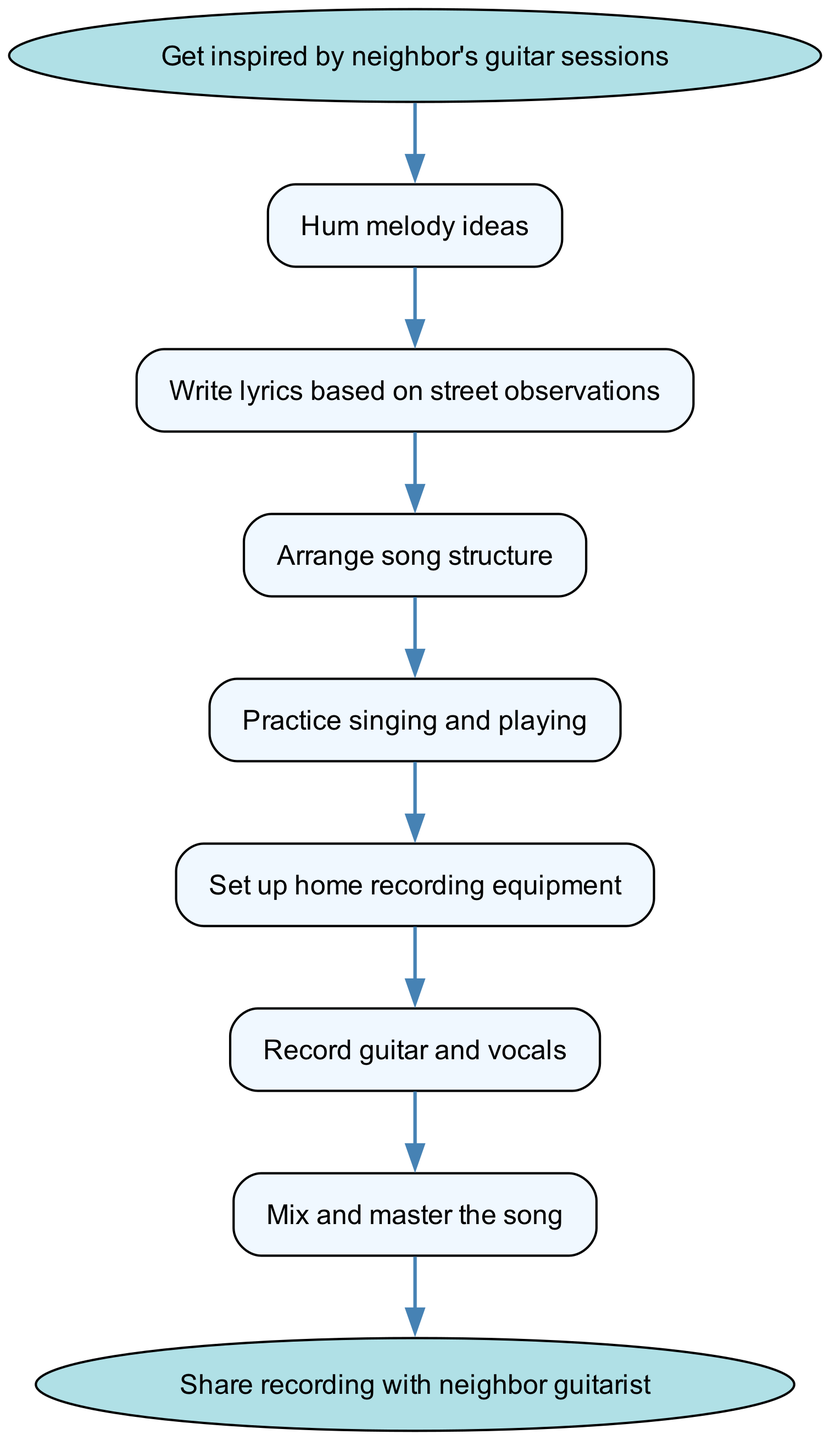What's the first step in the song writing process? The diagram starts with the node labeled "Get inspired by neighbor's guitar sessions," which indicates the beginning of the process.
Answer: Get inspired by neighbor's guitar sessions How many steps are there in the process of writing and recording an original song? Counting the nodes in the diagram from the start to the end includes "Get inspired by neighbor's guitar sessions," "Hum melody ideas," "Write lyrics based on street observations," "Arrange song structure," "Practice singing and playing," "Set up home recording equipment," "Record guitar and vocals," "Mix and master the song," and "Share recording with neighbor guitarist," totaling 8 steps.
Answer: 8 What do you do after you hum melody ideas? The diagram shows that after "Hum melody ideas," the next step is "Write lyrics based on street observations."
Answer: Write lyrics based on street observations Which step comes before recording guitar and vocals? Looking at the connections in the diagram, "Set up home recording equipment" is listed immediately before "Record guitar and vocals."
Answer: Set up home recording equipment What is the final action in the process? The last action in the flow chart, represented by the end node, is "Share recording with neighbor guitarist."
Answer: Share recording with neighbor guitarist What is the main task during step three? According to the diagram, step three is "Arrange song structure," indicating that the main task is to structure the song before proceeding further.
Answer: Arrange song structure Which step directly follows practicing singing and playing? The connection in the diagram shows that "Set up home recording equipment" is the next step that follows "Practice singing and playing."
Answer: Set up home recording equipment How is the song shared after completion? The diagram indicates that the song is shared by directly stating "Share recording with neighbor guitarist," which is the final step.
Answer: Share recording with neighbor guitarist What two components are recorded together in step six? Referring to the diagram, step six mentions "Record guitar and vocals," indicating that both guitar and vocals are recorded simultaneously.
Answer: Guitar and vocals 